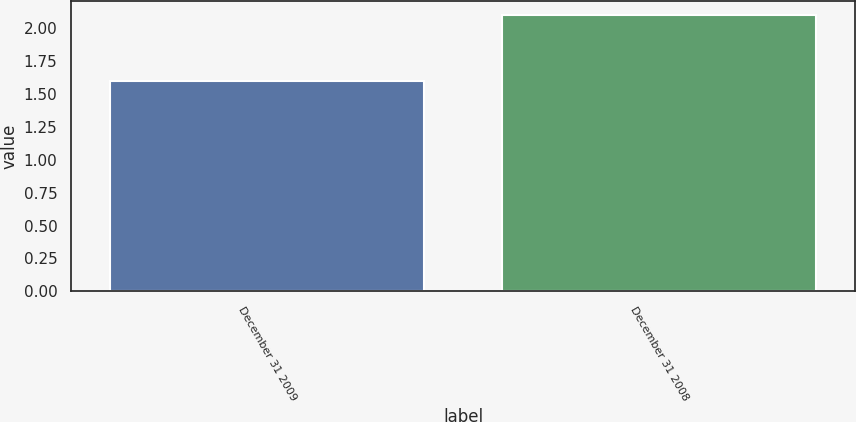<chart> <loc_0><loc_0><loc_500><loc_500><bar_chart><fcel>December 31 2009<fcel>December 31 2008<nl><fcel>1.6<fcel>2.1<nl></chart> 